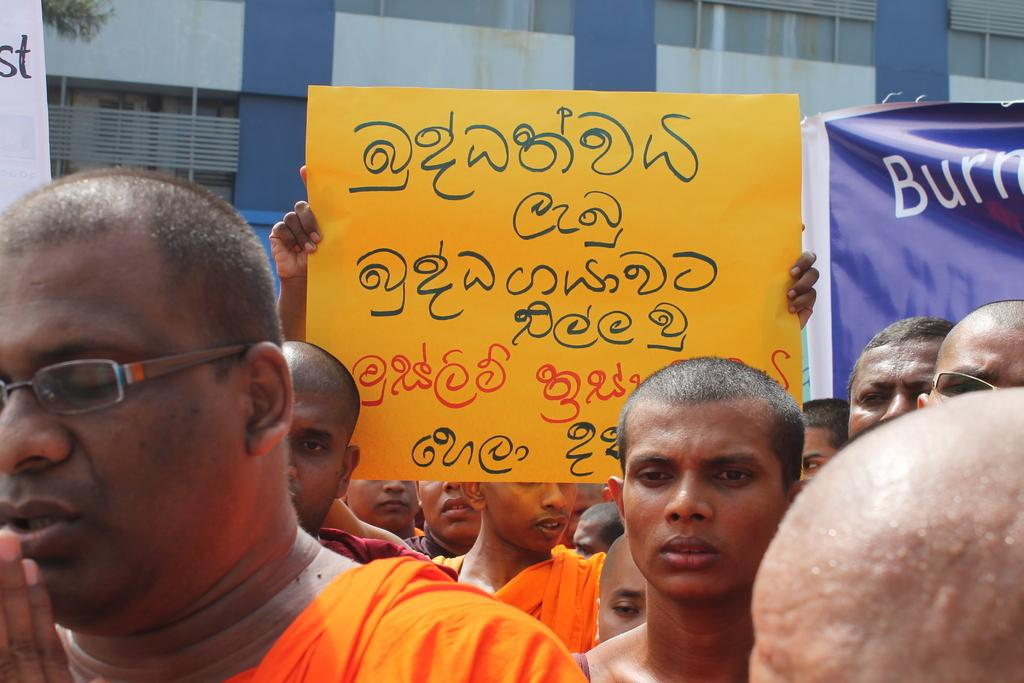What is happening in the image involving the group of people? The people in the image are holding placards in their hands. What can be seen in the background of the image? There is a building in the background of the image. What is the color of the building? The building is blue in color. What type of cord is being used to tie the pigs together in the image? There are no pigs or cords present in the image; it features a group of people holding placards and a blue building in the background. 